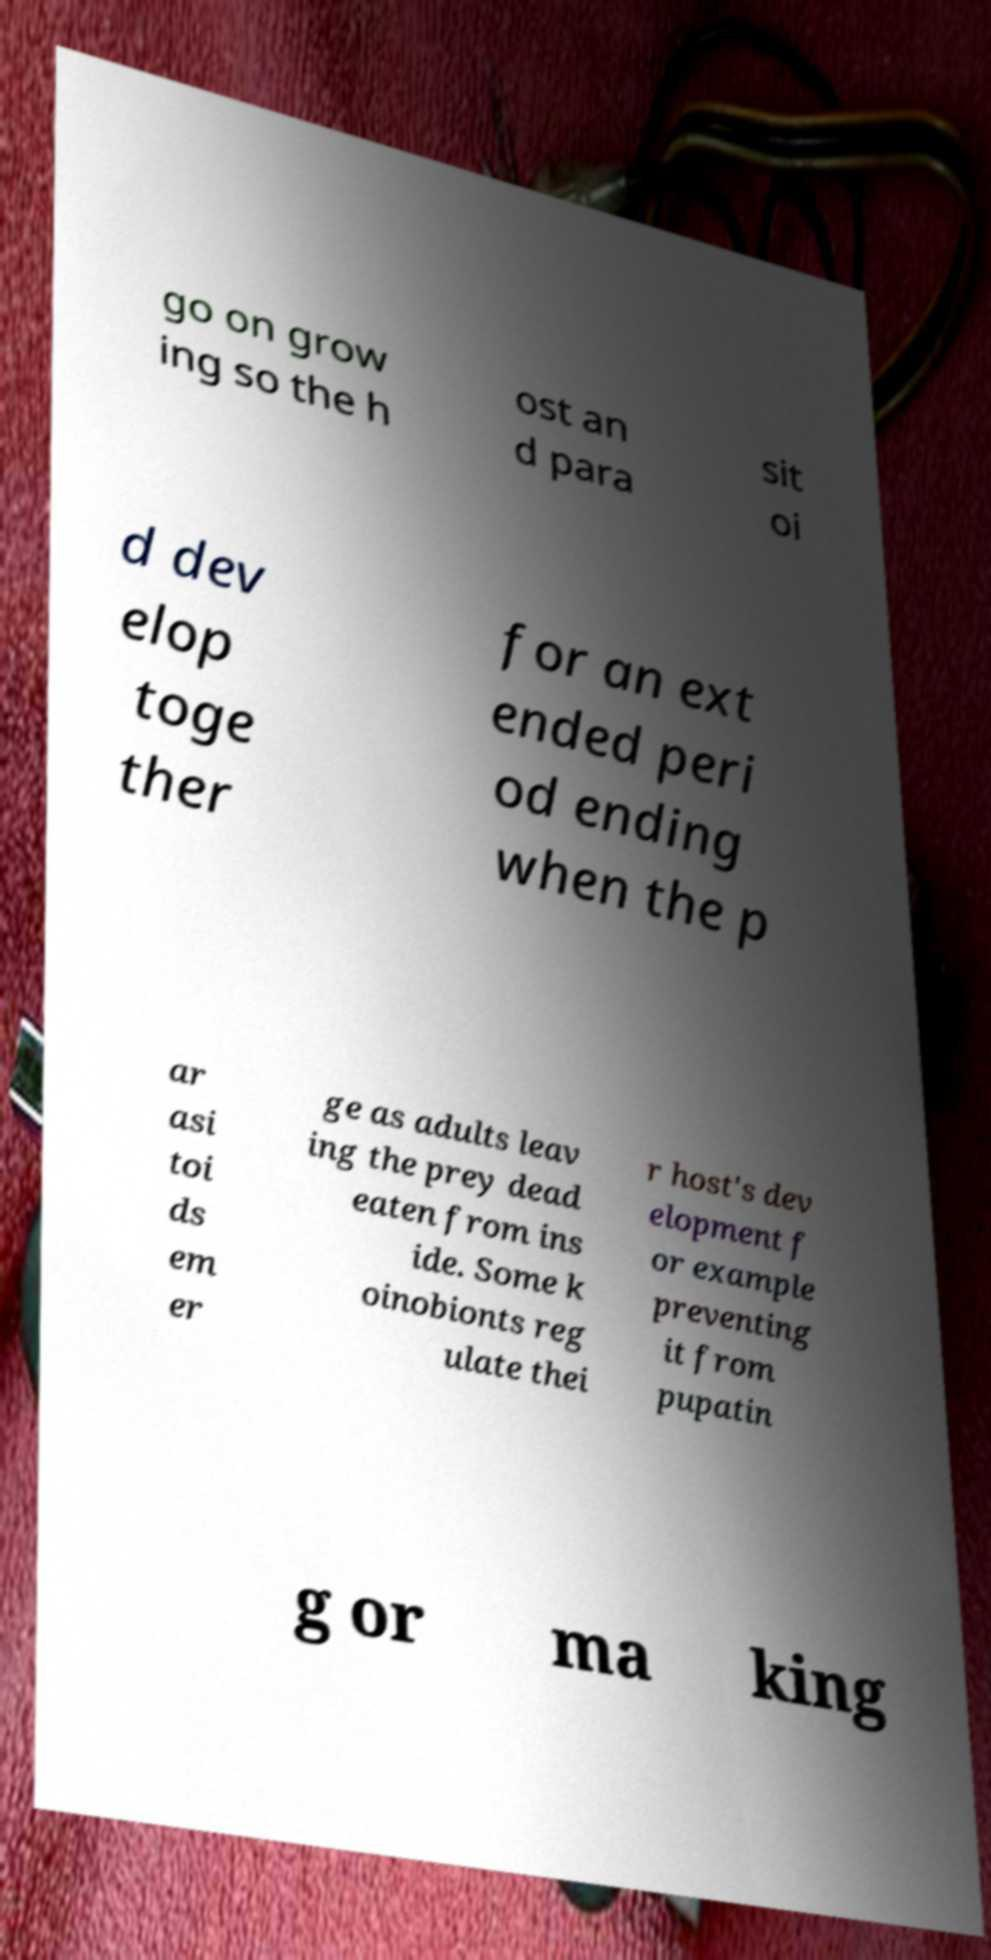What messages or text are displayed in this image? I need them in a readable, typed format. go on grow ing so the h ost an d para sit oi d dev elop toge ther for an ext ended peri od ending when the p ar asi toi ds em er ge as adults leav ing the prey dead eaten from ins ide. Some k oinobionts reg ulate thei r host's dev elopment f or example preventing it from pupatin g or ma king 